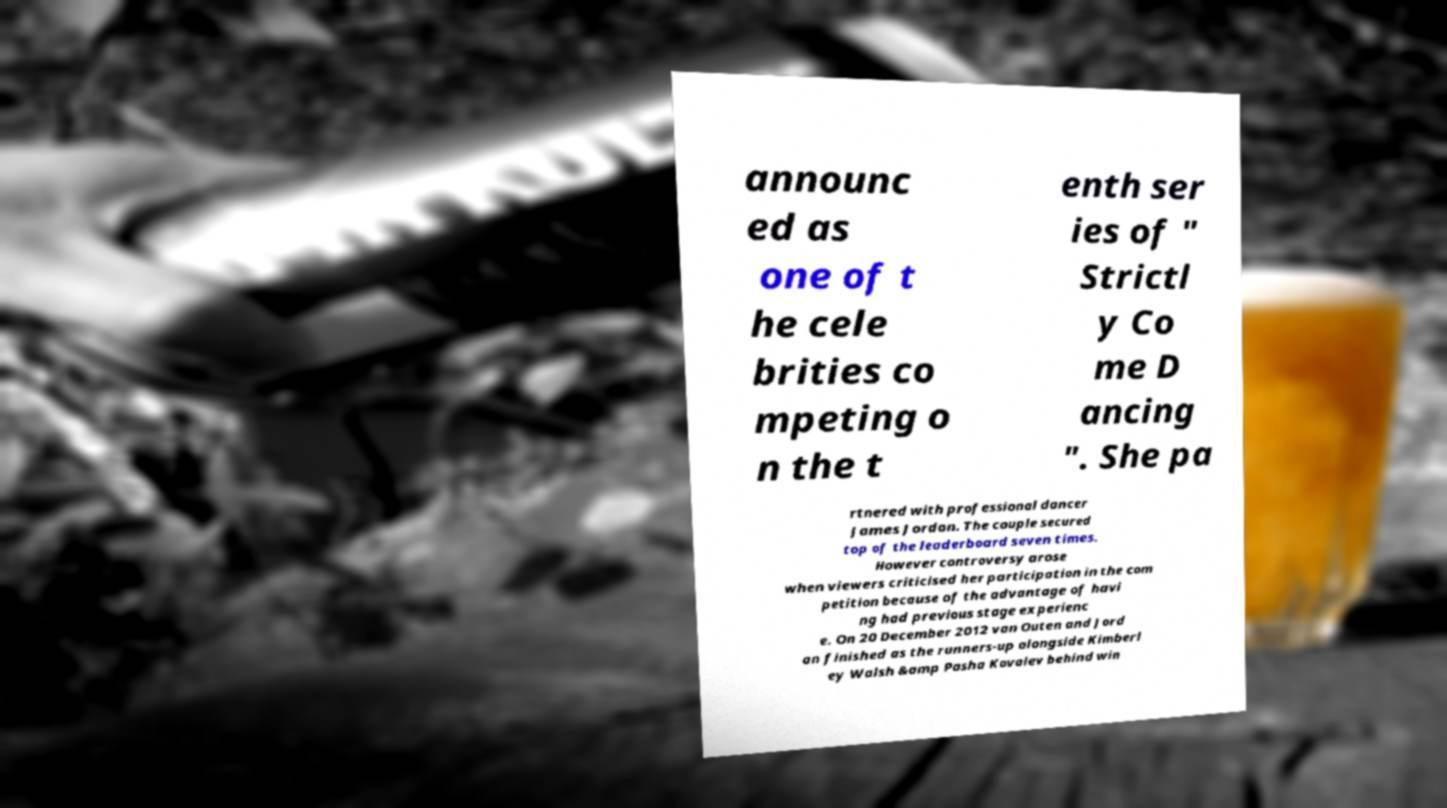Could you assist in decoding the text presented in this image and type it out clearly? announc ed as one of t he cele brities co mpeting o n the t enth ser ies of " Strictl y Co me D ancing ". She pa rtnered with professional dancer James Jordan. The couple secured top of the leaderboard seven times. However controversy arose when viewers criticised her participation in the com petition because of the advantage of havi ng had previous stage experienc e. On 20 December 2012 van Outen and Jord an finished as the runners-up alongside Kimberl ey Walsh &amp Pasha Kovalev behind win 